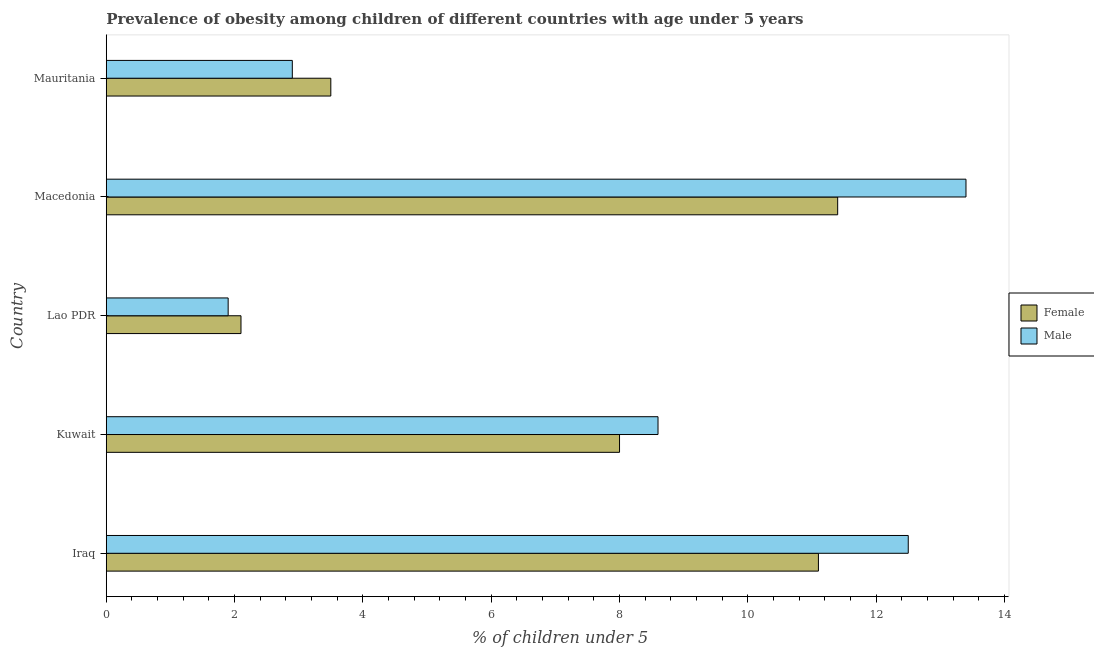How many groups of bars are there?
Provide a short and direct response. 5. Are the number of bars on each tick of the Y-axis equal?
Your response must be concise. Yes. How many bars are there on the 3rd tick from the top?
Keep it short and to the point. 2. What is the label of the 3rd group of bars from the top?
Provide a short and direct response. Lao PDR. What is the percentage of obese male children in Macedonia?
Offer a very short reply. 13.4. Across all countries, what is the maximum percentage of obese male children?
Your response must be concise. 13.4. Across all countries, what is the minimum percentage of obese female children?
Keep it short and to the point. 2.1. In which country was the percentage of obese female children maximum?
Offer a terse response. Macedonia. In which country was the percentage of obese male children minimum?
Keep it short and to the point. Lao PDR. What is the total percentage of obese female children in the graph?
Provide a short and direct response. 36.1. What is the difference between the percentage of obese male children in Macedonia and the percentage of obese female children in Iraq?
Give a very brief answer. 2.3. What is the average percentage of obese male children per country?
Give a very brief answer. 7.86. In how many countries, is the percentage of obese male children greater than 12.8 %?
Keep it short and to the point. 1. What is the ratio of the percentage of obese female children in Kuwait to that in Mauritania?
Your answer should be compact. 2.29. Is the percentage of obese male children in Iraq less than that in Macedonia?
Provide a succinct answer. Yes. Is the difference between the percentage of obese female children in Lao PDR and Macedonia greater than the difference between the percentage of obese male children in Lao PDR and Macedonia?
Your response must be concise. Yes. What is the difference between the highest and the lowest percentage of obese female children?
Offer a very short reply. 9.3. What does the 2nd bar from the top in Macedonia represents?
Your answer should be compact. Female. What does the 2nd bar from the bottom in Macedonia represents?
Provide a short and direct response. Male. How many bars are there?
Your response must be concise. 10. Are all the bars in the graph horizontal?
Your response must be concise. Yes. Does the graph contain any zero values?
Ensure brevity in your answer.  No. Does the graph contain grids?
Your response must be concise. No. Where does the legend appear in the graph?
Keep it short and to the point. Center right. How many legend labels are there?
Your response must be concise. 2. How are the legend labels stacked?
Your response must be concise. Vertical. What is the title of the graph?
Make the answer very short. Prevalence of obesity among children of different countries with age under 5 years. Does "Adolescent fertility rate" appear as one of the legend labels in the graph?
Keep it short and to the point. No. What is the label or title of the X-axis?
Provide a short and direct response.  % of children under 5. What is the  % of children under 5 of Female in Iraq?
Give a very brief answer. 11.1. What is the  % of children under 5 of Male in Iraq?
Offer a very short reply. 12.5. What is the  % of children under 5 in Female in Kuwait?
Your answer should be very brief. 8. What is the  % of children under 5 in Male in Kuwait?
Offer a very short reply. 8.6. What is the  % of children under 5 of Female in Lao PDR?
Your response must be concise. 2.1. What is the  % of children under 5 in Male in Lao PDR?
Keep it short and to the point. 1.9. What is the  % of children under 5 of Female in Macedonia?
Make the answer very short. 11.4. What is the  % of children under 5 of Male in Macedonia?
Your answer should be very brief. 13.4. What is the  % of children under 5 in Male in Mauritania?
Ensure brevity in your answer.  2.9. Across all countries, what is the maximum  % of children under 5 of Female?
Give a very brief answer. 11.4. Across all countries, what is the maximum  % of children under 5 of Male?
Offer a very short reply. 13.4. Across all countries, what is the minimum  % of children under 5 of Female?
Offer a very short reply. 2.1. Across all countries, what is the minimum  % of children under 5 of Male?
Offer a very short reply. 1.9. What is the total  % of children under 5 of Female in the graph?
Offer a very short reply. 36.1. What is the total  % of children under 5 of Male in the graph?
Your answer should be very brief. 39.3. What is the difference between the  % of children under 5 in Female in Iraq and that in Kuwait?
Give a very brief answer. 3.1. What is the difference between the  % of children under 5 of Female in Iraq and that in Lao PDR?
Ensure brevity in your answer.  9. What is the difference between the  % of children under 5 in Male in Iraq and that in Lao PDR?
Provide a succinct answer. 10.6. What is the difference between the  % of children under 5 in Male in Iraq and that in Macedonia?
Give a very brief answer. -0.9. What is the difference between the  % of children under 5 in Male in Iraq and that in Mauritania?
Your answer should be compact. 9.6. What is the difference between the  % of children under 5 of Female in Kuwait and that in Macedonia?
Provide a short and direct response. -3.4. What is the difference between the  % of children under 5 in Male in Kuwait and that in Macedonia?
Provide a succinct answer. -4.8. What is the difference between the  % of children under 5 of Female in Kuwait and that in Mauritania?
Keep it short and to the point. 4.5. What is the difference between the  % of children under 5 of Male in Kuwait and that in Mauritania?
Your answer should be compact. 5.7. What is the difference between the  % of children under 5 in Male in Lao PDR and that in Mauritania?
Your answer should be very brief. -1. What is the difference between the  % of children under 5 in Female in Iraq and the  % of children under 5 in Male in Kuwait?
Keep it short and to the point. 2.5. What is the difference between the  % of children under 5 of Female in Iraq and the  % of children under 5 of Male in Macedonia?
Your answer should be very brief. -2.3. What is the difference between the  % of children under 5 in Female in Kuwait and the  % of children under 5 in Male in Macedonia?
Ensure brevity in your answer.  -5.4. What is the difference between the  % of children under 5 in Female in Macedonia and the  % of children under 5 in Male in Mauritania?
Offer a terse response. 8.5. What is the average  % of children under 5 in Female per country?
Ensure brevity in your answer.  7.22. What is the average  % of children under 5 in Male per country?
Keep it short and to the point. 7.86. What is the difference between the  % of children under 5 of Female and  % of children under 5 of Male in Kuwait?
Offer a terse response. -0.6. What is the difference between the  % of children under 5 of Female and  % of children under 5 of Male in Lao PDR?
Provide a succinct answer. 0.2. What is the difference between the  % of children under 5 in Female and  % of children under 5 in Male in Macedonia?
Keep it short and to the point. -2. What is the ratio of the  % of children under 5 of Female in Iraq to that in Kuwait?
Offer a very short reply. 1.39. What is the ratio of the  % of children under 5 of Male in Iraq to that in Kuwait?
Provide a short and direct response. 1.45. What is the ratio of the  % of children under 5 in Female in Iraq to that in Lao PDR?
Your answer should be very brief. 5.29. What is the ratio of the  % of children under 5 of Male in Iraq to that in Lao PDR?
Provide a short and direct response. 6.58. What is the ratio of the  % of children under 5 in Female in Iraq to that in Macedonia?
Ensure brevity in your answer.  0.97. What is the ratio of the  % of children under 5 in Male in Iraq to that in Macedonia?
Offer a terse response. 0.93. What is the ratio of the  % of children under 5 in Female in Iraq to that in Mauritania?
Offer a very short reply. 3.17. What is the ratio of the  % of children under 5 of Male in Iraq to that in Mauritania?
Provide a short and direct response. 4.31. What is the ratio of the  % of children under 5 of Female in Kuwait to that in Lao PDR?
Ensure brevity in your answer.  3.81. What is the ratio of the  % of children under 5 of Male in Kuwait to that in Lao PDR?
Ensure brevity in your answer.  4.53. What is the ratio of the  % of children under 5 in Female in Kuwait to that in Macedonia?
Your answer should be compact. 0.7. What is the ratio of the  % of children under 5 of Male in Kuwait to that in Macedonia?
Your response must be concise. 0.64. What is the ratio of the  % of children under 5 in Female in Kuwait to that in Mauritania?
Ensure brevity in your answer.  2.29. What is the ratio of the  % of children under 5 in Male in Kuwait to that in Mauritania?
Offer a very short reply. 2.97. What is the ratio of the  % of children under 5 in Female in Lao PDR to that in Macedonia?
Your response must be concise. 0.18. What is the ratio of the  % of children under 5 in Male in Lao PDR to that in Macedonia?
Offer a terse response. 0.14. What is the ratio of the  % of children under 5 of Male in Lao PDR to that in Mauritania?
Ensure brevity in your answer.  0.66. What is the ratio of the  % of children under 5 of Female in Macedonia to that in Mauritania?
Offer a terse response. 3.26. What is the ratio of the  % of children under 5 in Male in Macedonia to that in Mauritania?
Offer a very short reply. 4.62. What is the difference between the highest and the second highest  % of children under 5 of Female?
Give a very brief answer. 0.3. What is the difference between the highest and the lowest  % of children under 5 of Female?
Your response must be concise. 9.3. 